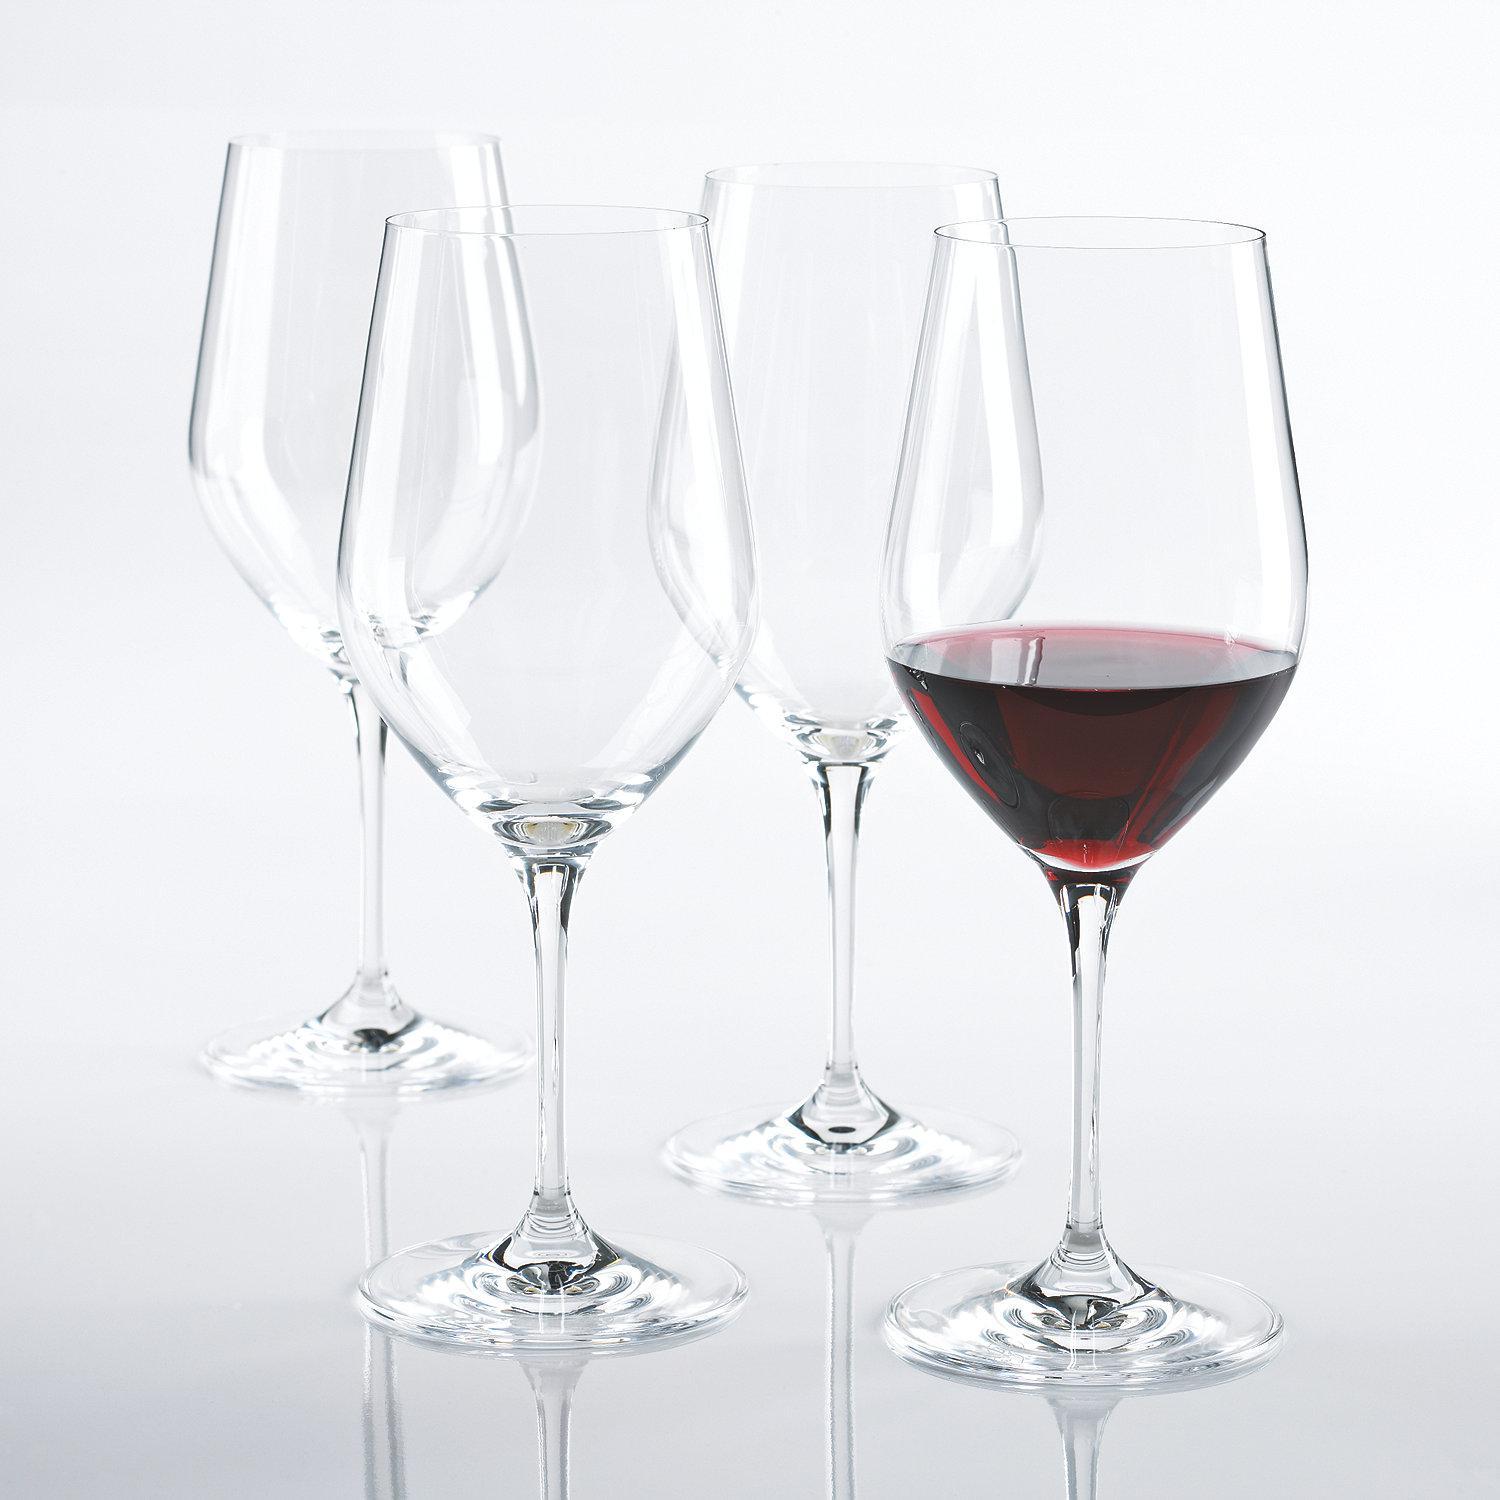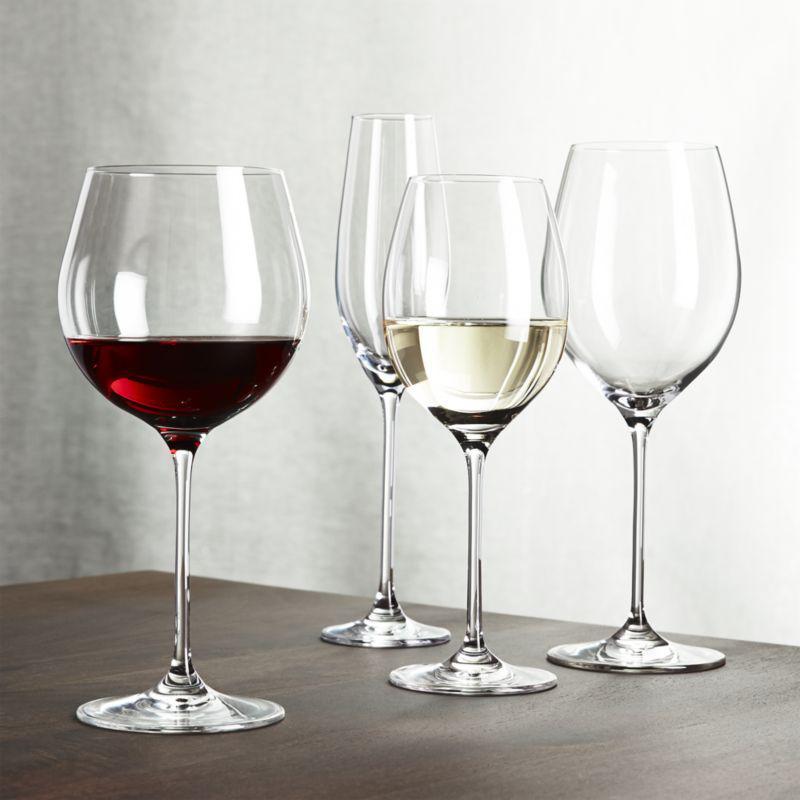The first image is the image on the left, the second image is the image on the right. Given the left and right images, does the statement "In one image, two glasses are right next to each other, and in the other, four glasses are arranged so some are in front of others." hold true? Answer yes or no. No. The first image is the image on the left, the second image is the image on the right. For the images displayed, is the sentence "In the left image, there is one glass of red wine and three empty wine glasses" factually correct? Answer yes or no. Yes. 